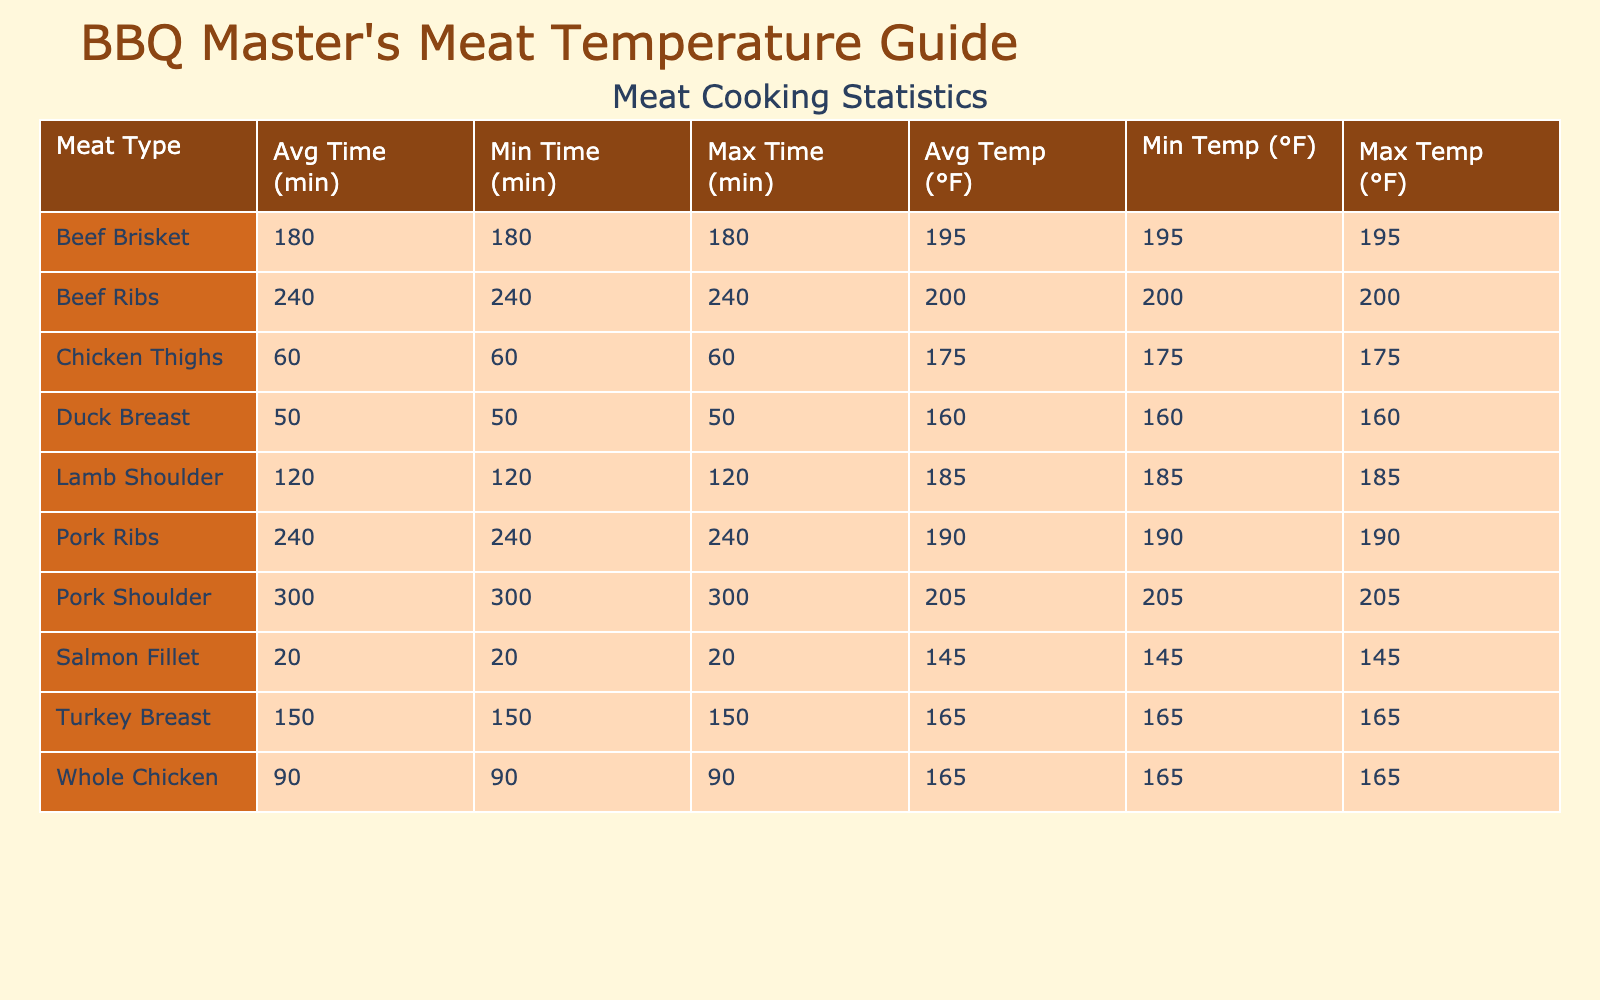What is the average internal temperature for Pork Ribs? The table lists Pork Ribs with an average internal temperature of 190°F. This value is directly accessible under the 'Average Internal Temperature Fahrenheit' column for Pork Ribs.
Answer: 190°F Which meat type has the highest average internal temperature? By comparing the average internal temperatures for all meat types listed, Pork Shoulder has the highest temperature at 205°F. This is the maximum under the 'Average Internal Temperature Fahrenheit' column.
Answer: Pork Shoulder What is the cooking time range for whole chicken? The cooking time for Whole Chicken shows a minimum of 90 minutes, as that is the only entry for Whole Chicken. The maximum is also 90 minutes since it's just a single value listed under 'Cooking Time Minutes'.
Answer: 90 minutes How much longer does it typically take to cook Pork Shoulder compared to Chicken Thighs? Pork Shoulder takes 300 minutes to cook, while Chicken Thighs take 60 minutes. By subtracting the cooking time of Chicken Thighs from that of Pork Shoulder, we get 300 - 60 = 240 minutes.
Answer: 240 minutes Is the average internal temperature for Duck Breast greater than that for Whole Chicken? Duck Breast has an average internal temperature of 160°F while Whole Chicken has 165°F. Since 160°F is less than 165°F, the statement is false.
Answer: No What is the difference in average internal temperature between Beef Ribs and Salmon Fillet? Beef Ribs have an average internal temperature of 200°F, while Salmon Fillet has 145°F. Calculating the difference gives us 200 - 145 = 55°F, showing that Beef Ribs are cooked to a higher temperature.
Answer: 55°F Which meat type takes the shortest time to cook? The table lists Salmon Fillet with a cooking time of 20 minutes, which is the minimum under the 'Cooking Time Minutes' column for all meats.
Answer: Salmon Fillet Does Turkey Breast require a longer cooking time than Chicken Thighs? Turkey Breast takes 150 minutes, and Chicken Thighs takes 60 minutes. Since 150 minutes is indeed greater than 60 minutes, the statement is true.
Answer: Yes What is the range of average internal temperatures across the different meats? To find the range, we need to look for the highest and lowest average internal temperatures. The lowest is 145°F (Salmon Fillet) and the highest is 205°F (Pork Shoulder). The range can be calculated as 205 - 145 = 60°F.
Answer: 60°F 